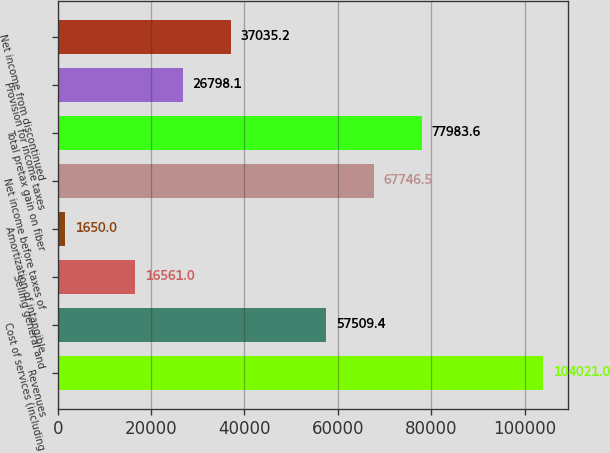Convert chart to OTSL. <chart><loc_0><loc_0><loc_500><loc_500><bar_chart><fcel>Revenues<fcel>Cost of services (including<fcel>Selling general and<fcel>Amortization of intangible<fcel>Net income before taxes of<fcel>Total pretax gain on fiber<fcel>Provision for income taxes<fcel>Net income from discontinued<nl><fcel>104021<fcel>57509.4<fcel>16561<fcel>1650<fcel>67746.5<fcel>77983.6<fcel>26798.1<fcel>37035.2<nl></chart> 